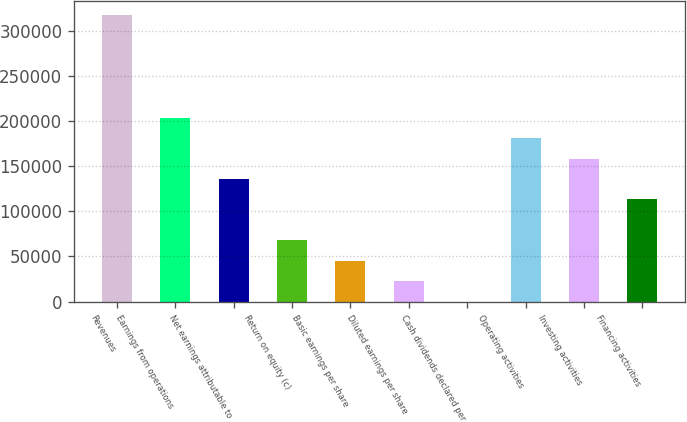Convert chart. <chart><loc_0><loc_0><loc_500><loc_500><bar_chart><fcel>Revenues<fcel>Earnings from operations<fcel>Net earnings attributable to<fcel>Return on equity (c)<fcel>Basic earnings per share<fcel>Diluted earnings per share<fcel>Cash dividends declared per<fcel>Operating activities<fcel>Investing activities<fcel>Financing activities<nl><fcel>316744<fcel>203623<fcel>135750<fcel>67876.5<fcel>45252.2<fcel>22627.8<fcel>3.45<fcel>180998<fcel>158374<fcel>113125<nl></chart> 